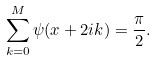Convert formula to latex. <formula><loc_0><loc_0><loc_500><loc_500>\sum _ { k = 0 } ^ { M } \psi ( x + 2 i k ) = \frac { \pi } { 2 } .</formula> 